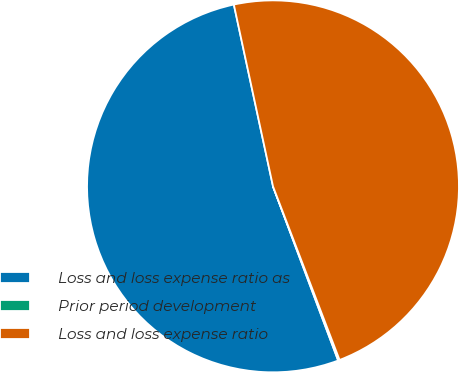<chart> <loc_0><loc_0><loc_500><loc_500><pie_chart><fcel>Loss and loss expense ratio as<fcel>Prior period development<fcel>Loss and loss expense ratio<nl><fcel>52.32%<fcel>0.13%<fcel>47.55%<nl></chart> 